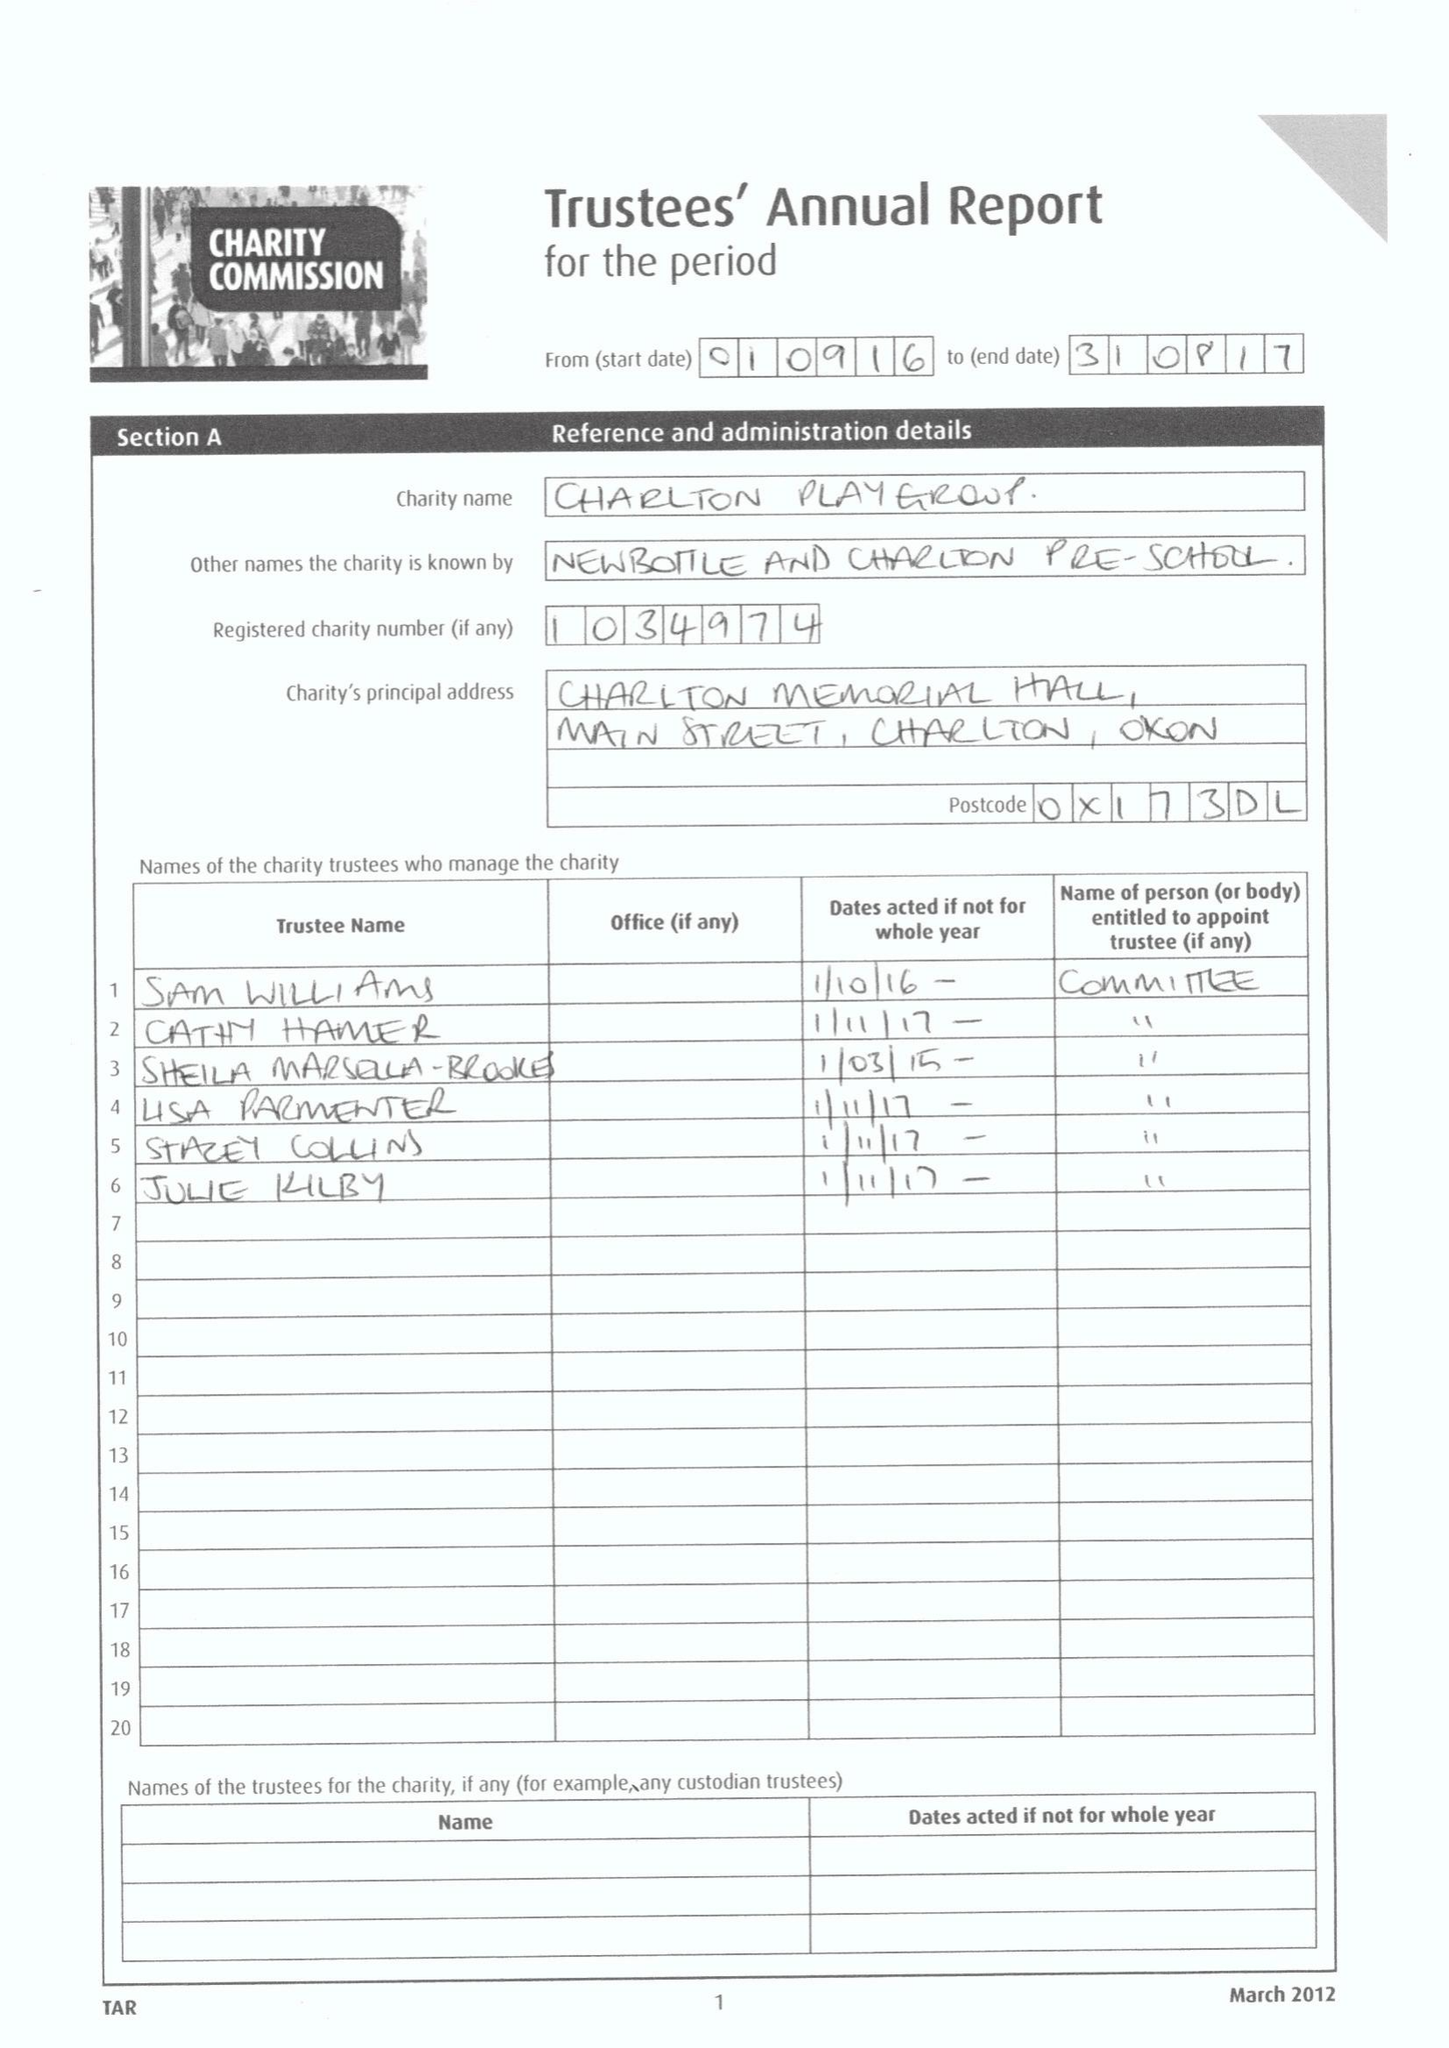What is the value for the spending_annually_in_british_pounds?
Answer the question using a single word or phrase. 48318.82 